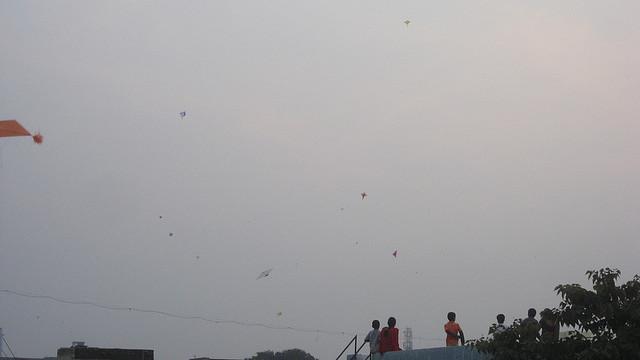How many people are standing?
Give a very brief answer. 6. How many people are in the picture?
Give a very brief answer. 6. 